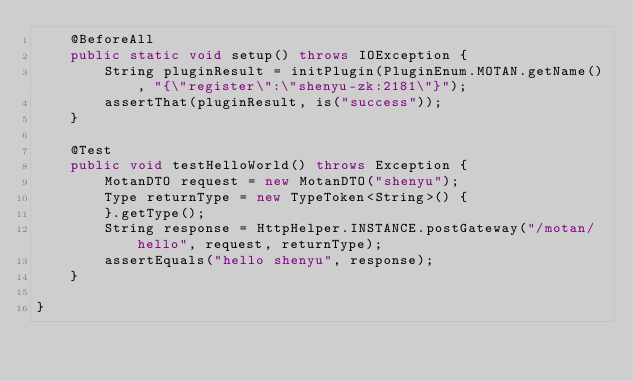<code> <loc_0><loc_0><loc_500><loc_500><_Java_>    @BeforeAll
    public static void setup() throws IOException {
        String pluginResult = initPlugin(PluginEnum.MOTAN.getName(), "{\"register\":\"shenyu-zk:2181\"}");
        assertThat(pluginResult, is("success"));
    }

    @Test
    public void testHelloWorld() throws Exception {
        MotanDTO request = new MotanDTO("shenyu");
        Type returnType = new TypeToken<String>() {
        }.getType();
        String response = HttpHelper.INSTANCE.postGateway("/motan/hello", request, returnType);
        assertEquals("hello shenyu", response);
    }

}
</code> 